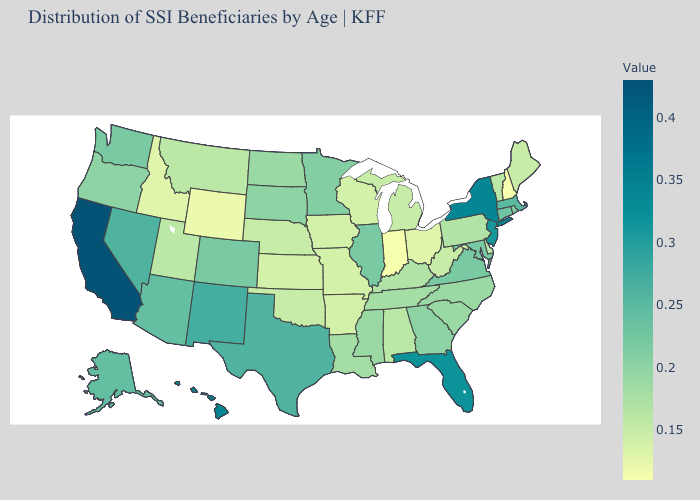Among the states that border New Mexico , does Texas have the lowest value?
Keep it brief. No. Does California have the highest value in the West?
Keep it brief. Yes. Among the states that border Texas , does Louisiana have the lowest value?
Answer briefly. No. Among the states that border New York , does Vermont have the lowest value?
Concise answer only. Yes. Does Florida have the highest value in the South?
Give a very brief answer. Yes. Among the states that border Washington , which have the lowest value?
Keep it brief. Idaho. 